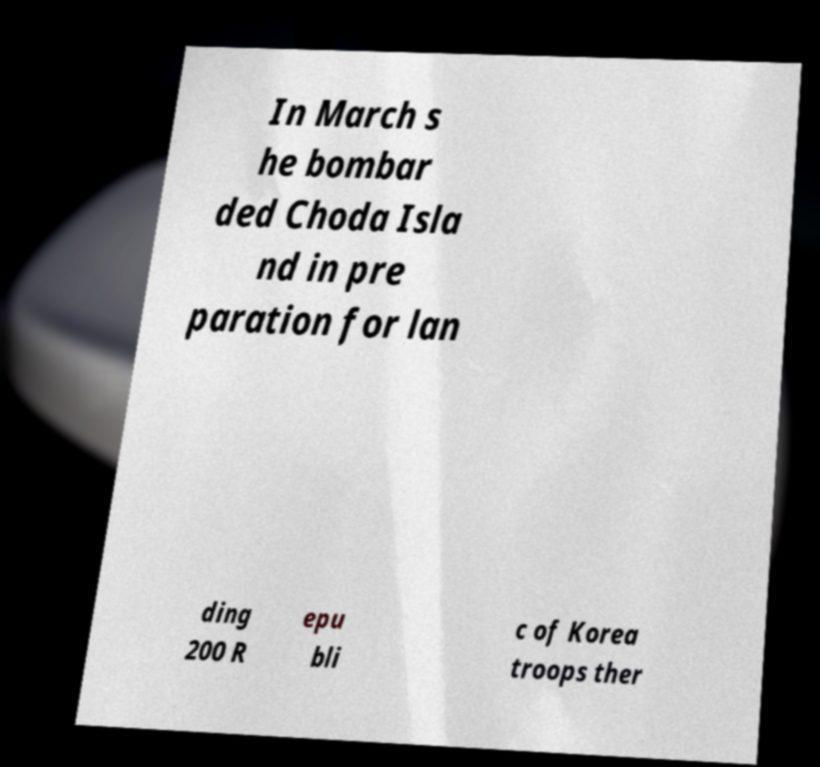Please identify and transcribe the text found in this image. In March s he bombar ded Choda Isla nd in pre paration for lan ding 200 R epu bli c of Korea troops ther 